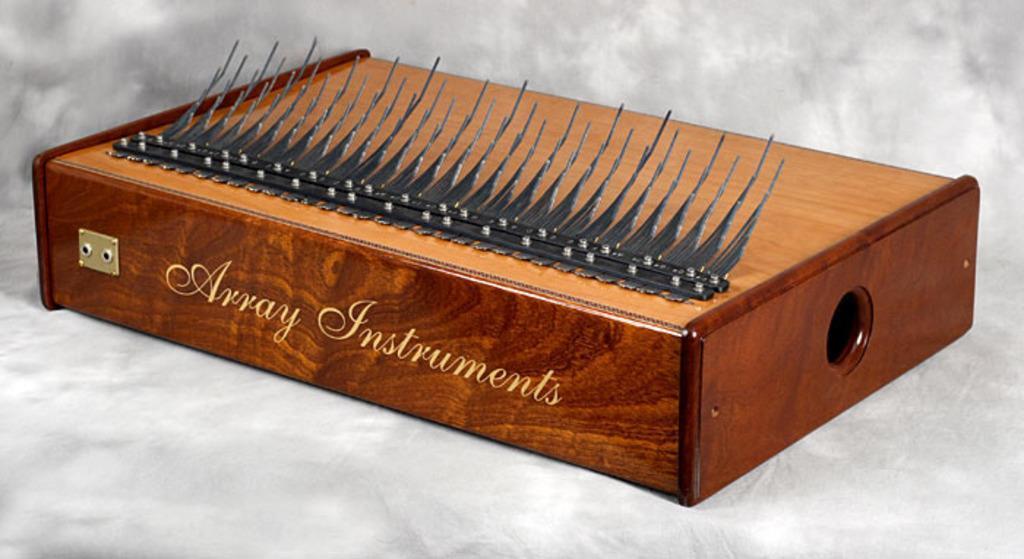How would you summarize this image in a sentence or two? In this picture we can see a wooden box and on the box it is written something and an item. The box is on a white object. 